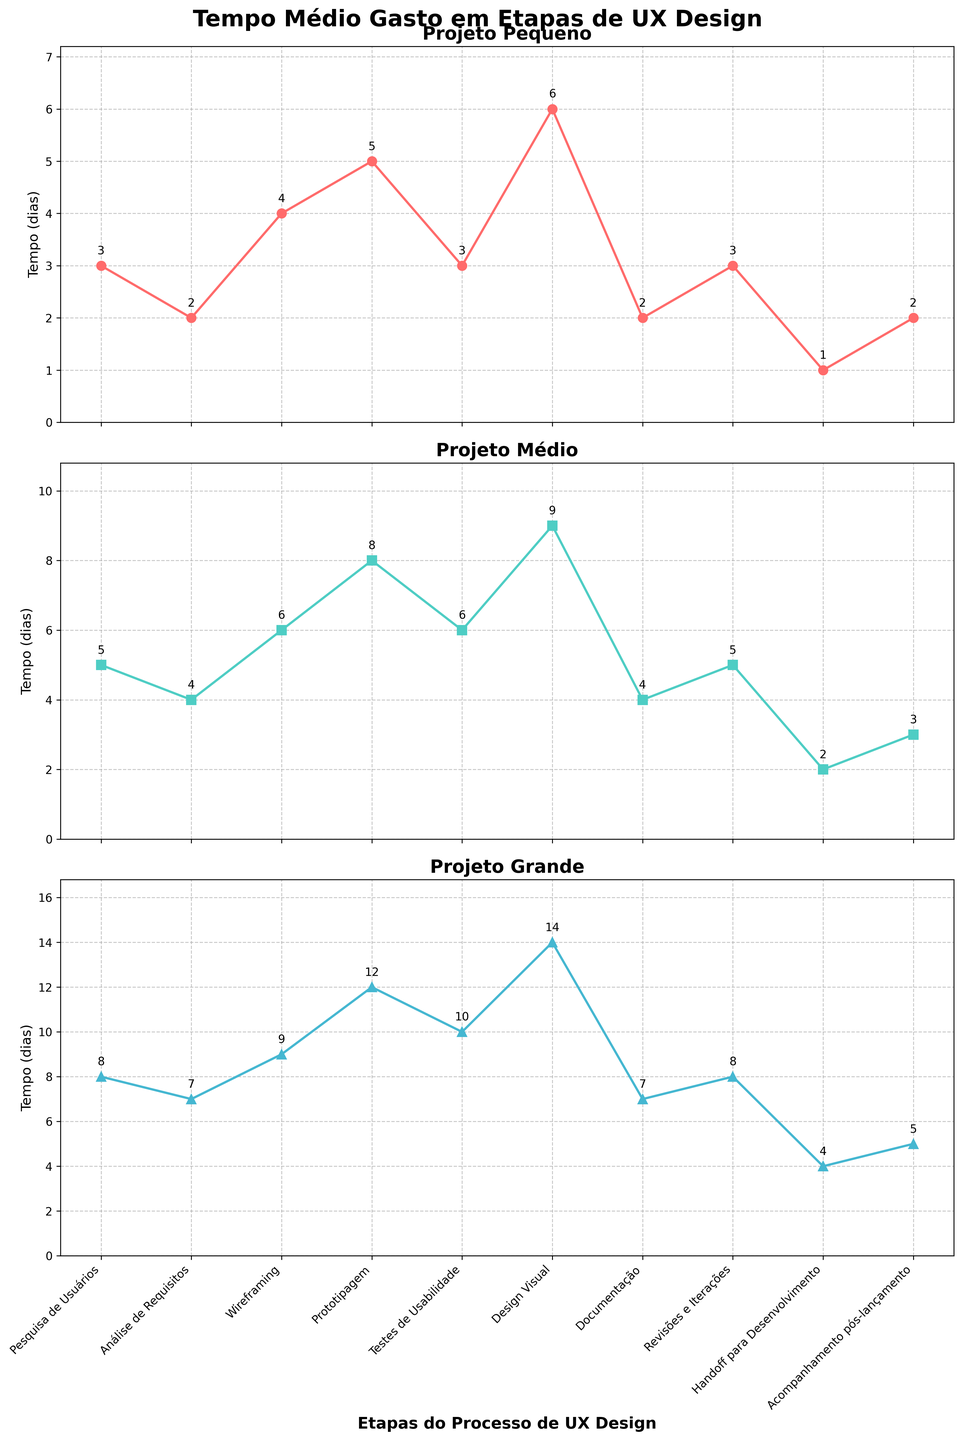Which etapa takes the most time for large projects? Observing the subplot for large projects, compare the time spent on each etapa. Design Visual has the highest value of 14 days.
Answer: Design Visual Which etapa takes the least time for small projects? Observing the subplot for small projects, compare the time spent on each etapa. Handoff para Desenvolvimento has the lowest value of 1 day.
Answer: Handoff para Desenvolvimento How much more time is spent on Prototipagem compared to Análise de Requisitos for medium projects? For medium projects, Prototipagem takes 8 days and Análise de Requisitos takes 4 days. The difference is 8 - 4 = 4 days.
Answer: 4 days Which etapa shows the greatest difference in time between small and large projects? Compare the values for each etapa in the small and large projects subplots. Design Visual has a difference of 14 - 6 = 8 days.
Answer: Design Visual What is the sum of time spent on Wireframing and Testes de Usabilidade for small projects? For small projects, Wireframing takes 4 days and Testes de Usabilidade takes 3 days. The sum is 4 + 3 = 7 days.
Answer: 7 days Which etapa has the same time allocation for both small and large projects? Compare the values for the same etapa across both small and large projects subplots. None of the etapas have the same time allocation for both small and large projects.
Answer: None What is the average time spent across all etapas for medium projects? Add up the time for all etapas for medium projects: 5+4+6+8+6+9+4+5+2+3=52 days. Divide by the number of etapas: 52/10 = 5.2 days.
Answer: 5.2 days Which projeto has the most consistent duration across different etapas? Compare the range of times (difference between highest and lowest) for each project. Small extends from 1 to 6 (range = 5), Medium extends from 2 to 9 (range = 7), Large extends from 4 to 14 (range = 10). Small has the smallest range, indicating the most consistency.
Answer: Small By how much does the time spent on Acompanhamento pós-lançamento increase from small to large projects? For small projects, Acompanhamento pós-lançamento takes 2 days and for large projects 5 days. The increase is 5 - 2 = 3 days.
Answer: 3 days 